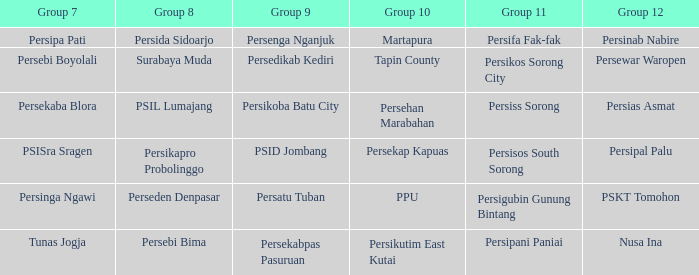Who took part in group 12 when group 9 faced psid jombang? Persipal Palu. 